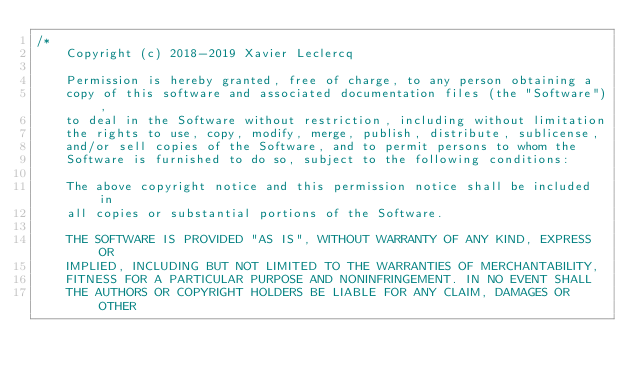Convert code to text. <code><loc_0><loc_0><loc_500><loc_500><_C++_>/*
    Copyright (c) 2018-2019 Xavier Leclercq

    Permission is hereby granted, free of charge, to any person obtaining a
    copy of this software and associated documentation files (the "Software"),
    to deal in the Software without restriction, including without limitation
    the rights to use, copy, modify, merge, publish, distribute, sublicense,
    and/or sell copies of the Software, and to permit persons to whom the
    Software is furnished to do so, subject to the following conditions:

    The above copyright notice and this permission notice shall be included in
    all copies or substantial portions of the Software.

    THE SOFTWARE IS PROVIDED "AS IS", WITHOUT WARRANTY OF ANY KIND, EXPRESS OR
    IMPLIED, INCLUDING BUT NOT LIMITED TO THE WARRANTIES OF MERCHANTABILITY,
    FITNESS FOR A PARTICULAR PURPOSE AND NONINFRINGEMENT. IN NO EVENT SHALL
    THE AUTHORS OR COPYRIGHT HOLDERS BE LIABLE FOR ANY CLAIM, DAMAGES OR OTHER</code> 